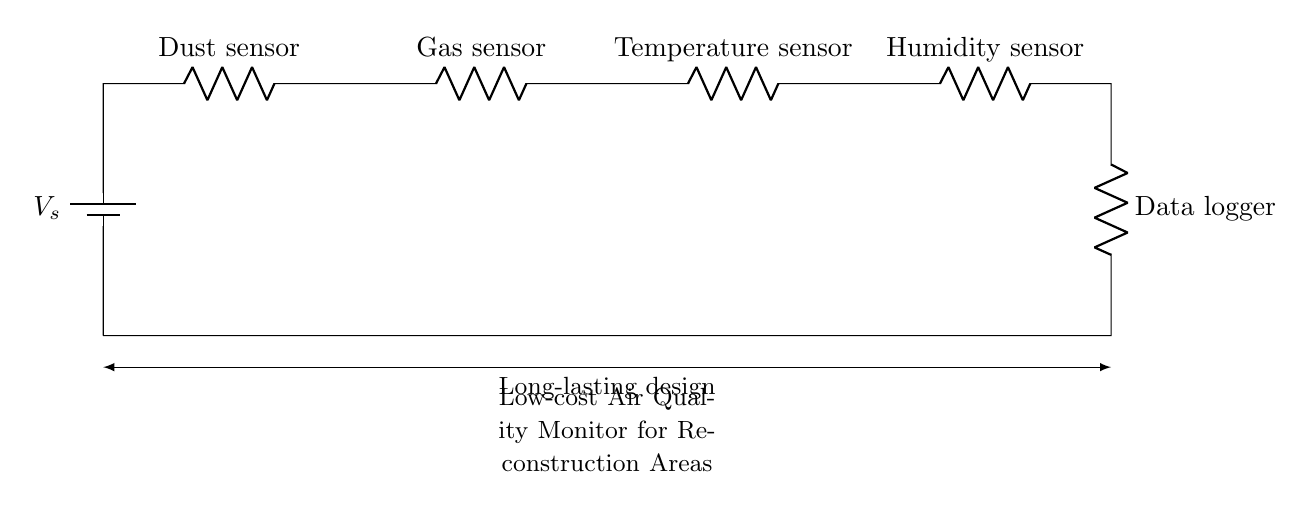What is the total number of components in this circuit? The circuit contains one battery, four sensors, and one data logger, which totals to six components.
Answer: six What type of circuit is shown in the diagram? The diagram depicts a series circuit, as all components are connected in a single path for current flow.
Answer: series Which sensor is used to measure humidity? The component labeled "Humidity sensor" indicates that this is the sensor used for measuring humidity in the circuit.
Answer: Humidity sensor What is the purpose of the data logger in this circuit? The data logger collects and stores the data from the sensors to provide information on air quality levels.
Answer: collect and store data What is the order of the sensors in the circuit? The sensors are connected in the order: Dust sensor, Gas sensor, Temperature sensor, and then Humidity sensor.
Answer: Dust, Gas, Temperature, Humidity How does adding more sensors affect this circuit? In a series circuit, adding more sensors increases the total resistance and can reduce the current flowing through the circuit, affecting readings.
Answer: reduces current 